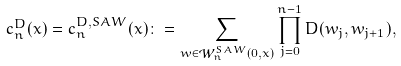<formula> <loc_0><loc_0><loc_500><loc_500>c ^ { D } _ { n } ( x ) = c ^ { D , S A W } _ { n } ( x ) & \colon = \sum _ { w \in \mathcal { W } _ { n } ^ { S A W } ( 0 , x ) } \prod _ { j = 0 } ^ { n - 1 } D ( w _ { j } , w _ { j + 1 } ) ,</formula> 